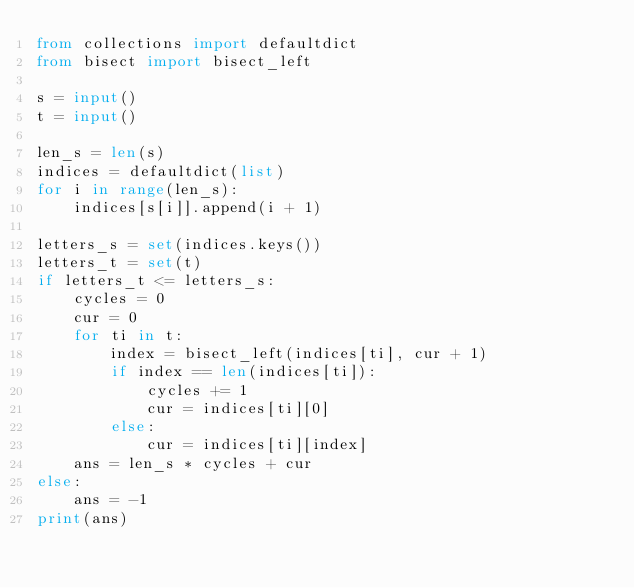<code> <loc_0><loc_0><loc_500><loc_500><_Python_>from collections import defaultdict
from bisect import bisect_left

s = input()
t = input()

len_s = len(s)
indices = defaultdict(list)
for i in range(len_s):
    indices[s[i]].append(i + 1)

letters_s = set(indices.keys())
letters_t = set(t)
if letters_t <= letters_s:
    cycles = 0
    cur = 0
    for ti in t:
        index = bisect_left(indices[ti], cur + 1)
        if index == len(indices[ti]):
            cycles += 1
            cur = indices[ti][0]
        else:
            cur = indices[ti][index]
    ans = len_s * cycles + cur
else:
    ans = -1
print(ans)
</code> 